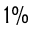<formula> <loc_0><loc_0><loc_500><loc_500>1 \%</formula> 